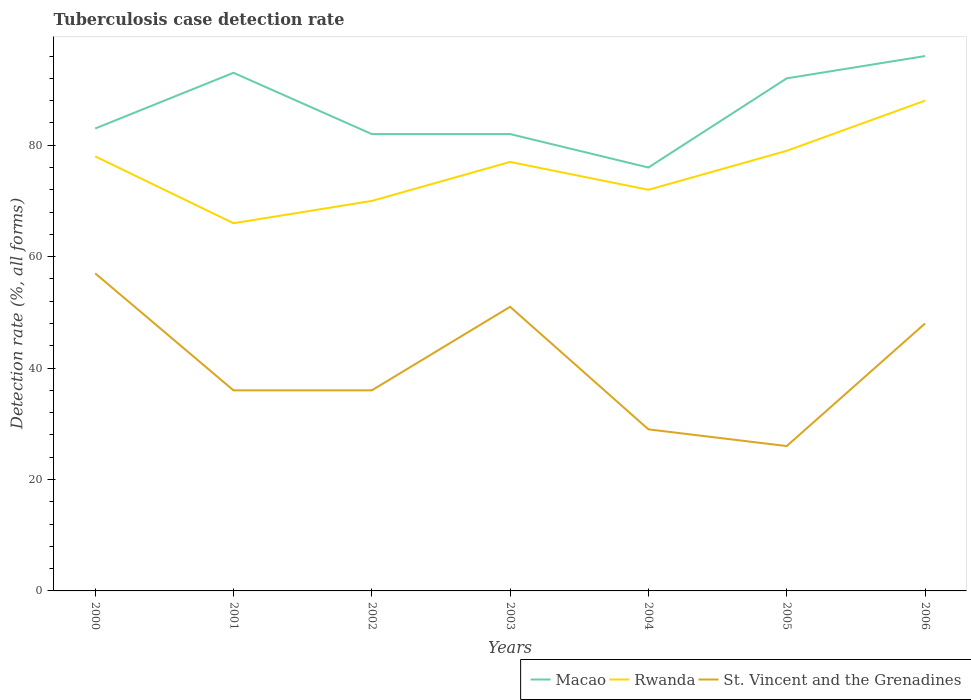Across all years, what is the maximum tuberculosis case detection rate in in Rwanda?
Provide a succinct answer. 66. What is the total tuberculosis case detection rate in in St. Vincent and the Grenadines in the graph?
Offer a terse response. 7. What is the difference between the highest and the second highest tuberculosis case detection rate in in St. Vincent and the Grenadines?
Ensure brevity in your answer.  31. What is the difference between the highest and the lowest tuberculosis case detection rate in in Macao?
Your response must be concise. 3. How many lines are there?
Provide a succinct answer. 3. What is the difference between two consecutive major ticks on the Y-axis?
Provide a short and direct response. 20. Does the graph contain grids?
Your answer should be compact. No. Where does the legend appear in the graph?
Offer a very short reply. Bottom right. How are the legend labels stacked?
Your response must be concise. Horizontal. What is the title of the graph?
Your answer should be very brief. Tuberculosis case detection rate. Does "Costa Rica" appear as one of the legend labels in the graph?
Give a very brief answer. No. What is the label or title of the X-axis?
Your response must be concise. Years. What is the label or title of the Y-axis?
Your answer should be compact. Detection rate (%, all forms). What is the Detection rate (%, all forms) of Macao in 2001?
Keep it short and to the point. 93. What is the Detection rate (%, all forms) of St. Vincent and the Grenadines in 2001?
Make the answer very short. 36. What is the Detection rate (%, all forms) of Macao in 2002?
Provide a succinct answer. 82. What is the Detection rate (%, all forms) in Macao in 2003?
Offer a terse response. 82. What is the Detection rate (%, all forms) in St. Vincent and the Grenadines in 2004?
Provide a succinct answer. 29. What is the Detection rate (%, all forms) of Macao in 2005?
Offer a terse response. 92. What is the Detection rate (%, all forms) in Rwanda in 2005?
Provide a succinct answer. 79. What is the Detection rate (%, all forms) of St. Vincent and the Grenadines in 2005?
Your response must be concise. 26. What is the Detection rate (%, all forms) in Macao in 2006?
Make the answer very short. 96. What is the Detection rate (%, all forms) in Rwanda in 2006?
Your answer should be very brief. 88. Across all years, what is the maximum Detection rate (%, all forms) of Macao?
Make the answer very short. 96. Across all years, what is the maximum Detection rate (%, all forms) of Rwanda?
Ensure brevity in your answer.  88. Across all years, what is the maximum Detection rate (%, all forms) in St. Vincent and the Grenadines?
Your response must be concise. 57. Across all years, what is the minimum Detection rate (%, all forms) of Macao?
Give a very brief answer. 76. Across all years, what is the minimum Detection rate (%, all forms) in St. Vincent and the Grenadines?
Keep it short and to the point. 26. What is the total Detection rate (%, all forms) of Macao in the graph?
Give a very brief answer. 604. What is the total Detection rate (%, all forms) in Rwanda in the graph?
Offer a very short reply. 530. What is the total Detection rate (%, all forms) in St. Vincent and the Grenadines in the graph?
Ensure brevity in your answer.  283. What is the difference between the Detection rate (%, all forms) in Macao in 2000 and that in 2001?
Provide a succinct answer. -10. What is the difference between the Detection rate (%, all forms) of Rwanda in 2000 and that in 2002?
Provide a short and direct response. 8. What is the difference between the Detection rate (%, all forms) of Rwanda in 2000 and that in 2003?
Your answer should be very brief. 1. What is the difference between the Detection rate (%, all forms) in St. Vincent and the Grenadines in 2000 and that in 2003?
Provide a short and direct response. 6. What is the difference between the Detection rate (%, all forms) of St. Vincent and the Grenadines in 2000 and that in 2004?
Your answer should be very brief. 28. What is the difference between the Detection rate (%, all forms) of St. Vincent and the Grenadines in 2000 and that in 2005?
Keep it short and to the point. 31. What is the difference between the Detection rate (%, all forms) of St. Vincent and the Grenadines in 2000 and that in 2006?
Your answer should be compact. 9. What is the difference between the Detection rate (%, all forms) in St. Vincent and the Grenadines in 2001 and that in 2002?
Provide a succinct answer. 0. What is the difference between the Detection rate (%, all forms) in Macao in 2001 and that in 2003?
Provide a succinct answer. 11. What is the difference between the Detection rate (%, all forms) in St. Vincent and the Grenadines in 2001 and that in 2003?
Offer a terse response. -15. What is the difference between the Detection rate (%, all forms) of Macao in 2001 and that in 2004?
Offer a very short reply. 17. What is the difference between the Detection rate (%, all forms) in St. Vincent and the Grenadines in 2001 and that in 2004?
Ensure brevity in your answer.  7. What is the difference between the Detection rate (%, all forms) of St. Vincent and the Grenadines in 2001 and that in 2005?
Make the answer very short. 10. What is the difference between the Detection rate (%, all forms) of Rwanda in 2001 and that in 2006?
Your response must be concise. -22. What is the difference between the Detection rate (%, all forms) in St. Vincent and the Grenadines in 2001 and that in 2006?
Make the answer very short. -12. What is the difference between the Detection rate (%, all forms) in Rwanda in 2002 and that in 2003?
Offer a terse response. -7. What is the difference between the Detection rate (%, all forms) in Macao in 2002 and that in 2004?
Your response must be concise. 6. What is the difference between the Detection rate (%, all forms) of Rwanda in 2002 and that in 2004?
Your answer should be compact. -2. What is the difference between the Detection rate (%, all forms) in St. Vincent and the Grenadines in 2002 and that in 2004?
Ensure brevity in your answer.  7. What is the difference between the Detection rate (%, all forms) in St. Vincent and the Grenadines in 2002 and that in 2005?
Provide a short and direct response. 10. What is the difference between the Detection rate (%, all forms) of Macao in 2002 and that in 2006?
Keep it short and to the point. -14. What is the difference between the Detection rate (%, all forms) of Rwanda in 2002 and that in 2006?
Provide a short and direct response. -18. What is the difference between the Detection rate (%, all forms) of St. Vincent and the Grenadines in 2002 and that in 2006?
Provide a short and direct response. -12. What is the difference between the Detection rate (%, all forms) in Macao in 2003 and that in 2004?
Offer a terse response. 6. What is the difference between the Detection rate (%, all forms) of St. Vincent and the Grenadines in 2003 and that in 2004?
Offer a very short reply. 22. What is the difference between the Detection rate (%, all forms) in Macao in 2003 and that in 2005?
Keep it short and to the point. -10. What is the difference between the Detection rate (%, all forms) of Rwanda in 2003 and that in 2005?
Keep it short and to the point. -2. What is the difference between the Detection rate (%, all forms) in St. Vincent and the Grenadines in 2003 and that in 2006?
Your answer should be compact. 3. What is the difference between the Detection rate (%, all forms) of Rwanda in 2004 and that in 2005?
Your answer should be compact. -7. What is the difference between the Detection rate (%, all forms) in Macao in 2004 and that in 2006?
Offer a very short reply. -20. What is the difference between the Detection rate (%, all forms) of Rwanda in 2004 and that in 2006?
Give a very brief answer. -16. What is the difference between the Detection rate (%, all forms) of Macao in 2005 and that in 2006?
Your answer should be very brief. -4. What is the difference between the Detection rate (%, all forms) of Rwanda in 2005 and that in 2006?
Your answer should be compact. -9. What is the difference between the Detection rate (%, all forms) of St. Vincent and the Grenadines in 2005 and that in 2006?
Your answer should be compact. -22. What is the difference between the Detection rate (%, all forms) of Macao in 2000 and the Detection rate (%, all forms) of Rwanda in 2001?
Provide a short and direct response. 17. What is the difference between the Detection rate (%, all forms) of Macao in 2000 and the Detection rate (%, all forms) of St. Vincent and the Grenadines in 2001?
Your answer should be very brief. 47. What is the difference between the Detection rate (%, all forms) in Rwanda in 2000 and the Detection rate (%, all forms) in St. Vincent and the Grenadines in 2002?
Offer a very short reply. 42. What is the difference between the Detection rate (%, all forms) in Macao in 2000 and the Detection rate (%, all forms) in St. Vincent and the Grenadines in 2003?
Provide a short and direct response. 32. What is the difference between the Detection rate (%, all forms) of Rwanda in 2000 and the Detection rate (%, all forms) of St. Vincent and the Grenadines in 2003?
Your answer should be very brief. 27. What is the difference between the Detection rate (%, all forms) in Macao in 2000 and the Detection rate (%, all forms) in St. Vincent and the Grenadines in 2004?
Offer a very short reply. 54. What is the difference between the Detection rate (%, all forms) of Macao in 2000 and the Detection rate (%, all forms) of Rwanda in 2005?
Offer a very short reply. 4. What is the difference between the Detection rate (%, all forms) of Macao in 2000 and the Detection rate (%, all forms) of Rwanda in 2006?
Your answer should be compact. -5. What is the difference between the Detection rate (%, all forms) in Macao in 2001 and the Detection rate (%, all forms) in Rwanda in 2002?
Make the answer very short. 23. What is the difference between the Detection rate (%, all forms) in Rwanda in 2001 and the Detection rate (%, all forms) in St. Vincent and the Grenadines in 2002?
Provide a short and direct response. 30. What is the difference between the Detection rate (%, all forms) of Macao in 2001 and the Detection rate (%, all forms) of Rwanda in 2003?
Keep it short and to the point. 16. What is the difference between the Detection rate (%, all forms) in Macao in 2001 and the Detection rate (%, all forms) in Rwanda in 2005?
Keep it short and to the point. 14. What is the difference between the Detection rate (%, all forms) of Macao in 2001 and the Detection rate (%, all forms) of St. Vincent and the Grenadines in 2005?
Make the answer very short. 67. What is the difference between the Detection rate (%, all forms) in Macao in 2001 and the Detection rate (%, all forms) in Rwanda in 2006?
Your response must be concise. 5. What is the difference between the Detection rate (%, all forms) in Macao in 2002 and the Detection rate (%, all forms) in Rwanda in 2003?
Offer a very short reply. 5. What is the difference between the Detection rate (%, all forms) of Macao in 2002 and the Detection rate (%, all forms) of Rwanda in 2004?
Give a very brief answer. 10. What is the difference between the Detection rate (%, all forms) in Macao in 2002 and the Detection rate (%, all forms) in St. Vincent and the Grenadines in 2004?
Ensure brevity in your answer.  53. What is the difference between the Detection rate (%, all forms) in Macao in 2002 and the Detection rate (%, all forms) in Rwanda in 2005?
Give a very brief answer. 3. What is the difference between the Detection rate (%, all forms) in Macao in 2002 and the Detection rate (%, all forms) in St. Vincent and the Grenadines in 2005?
Your answer should be compact. 56. What is the difference between the Detection rate (%, all forms) in Rwanda in 2002 and the Detection rate (%, all forms) in St. Vincent and the Grenadines in 2005?
Ensure brevity in your answer.  44. What is the difference between the Detection rate (%, all forms) of Macao in 2002 and the Detection rate (%, all forms) of Rwanda in 2006?
Provide a short and direct response. -6. What is the difference between the Detection rate (%, all forms) of Rwanda in 2002 and the Detection rate (%, all forms) of St. Vincent and the Grenadines in 2006?
Your answer should be very brief. 22. What is the difference between the Detection rate (%, all forms) of Macao in 2003 and the Detection rate (%, all forms) of Rwanda in 2004?
Your answer should be very brief. 10. What is the difference between the Detection rate (%, all forms) in Macao in 2003 and the Detection rate (%, all forms) in Rwanda in 2005?
Ensure brevity in your answer.  3. What is the difference between the Detection rate (%, all forms) of Macao in 2004 and the Detection rate (%, all forms) of Rwanda in 2005?
Offer a very short reply. -3. What is the difference between the Detection rate (%, all forms) of Macao in 2004 and the Detection rate (%, all forms) of St. Vincent and the Grenadines in 2005?
Offer a terse response. 50. What is the difference between the Detection rate (%, all forms) of Macao in 2004 and the Detection rate (%, all forms) of Rwanda in 2006?
Provide a short and direct response. -12. What is the difference between the Detection rate (%, all forms) in Macao in 2004 and the Detection rate (%, all forms) in St. Vincent and the Grenadines in 2006?
Your response must be concise. 28. What is the difference between the Detection rate (%, all forms) of Macao in 2005 and the Detection rate (%, all forms) of Rwanda in 2006?
Your answer should be very brief. 4. What is the difference between the Detection rate (%, all forms) of Macao in 2005 and the Detection rate (%, all forms) of St. Vincent and the Grenadines in 2006?
Keep it short and to the point. 44. What is the difference between the Detection rate (%, all forms) of Rwanda in 2005 and the Detection rate (%, all forms) of St. Vincent and the Grenadines in 2006?
Offer a terse response. 31. What is the average Detection rate (%, all forms) of Macao per year?
Offer a very short reply. 86.29. What is the average Detection rate (%, all forms) of Rwanda per year?
Your answer should be very brief. 75.71. What is the average Detection rate (%, all forms) in St. Vincent and the Grenadines per year?
Keep it short and to the point. 40.43. In the year 2000, what is the difference between the Detection rate (%, all forms) in Macao and Detection rate (%, all forms) in Rwanda?
Keep it short and to the point. 5. In the year 2000, what is the difference between the Detection rate (%, all forms) of Macao and Detection rate (%, all forms) of St. Vincent and the Grenadines?
Keep it short and to the point. 26. In the year 2001, what is the difference between the Detection rate (%, all forms) in Macao and Detection rate (%, all forms) in Rwanda?
Your response must be concise. 27. In the year 2002, what is the difference between the Detection rate (%, all forms) of Macao and Detection rate (%, all forms) of Rwanda?
Give a very brief answer. 12. In the year 2003, what is the difference between the Detection rate (%, all forms) in Rwanda and Detection rate (%, all forms) in St. Vincent and the Grenadines?
Make the answer very short. 26. In the year 2005, what is the difference between the Detection rate (%, all forms) in Macao and Detection rate (%, all forms) in Rwanda?
Provide a succinct answer. 13. In the year 2005, what is the difference between the Detection rate (%, all forms) in Rwanda and Detection rate (%, all forms) in St. Vincent and the Grenadines?
Your answer should be very brief. 53. In the year 2006, what is the difference between the Detection rate (%, all forms) in Macao and Detection rate (%, all forms) in Rwanda?
Offer a very short reply. 8. In the year 2006, what is the difference between the Detection rate (%, all forms) in Rwanda and Detection rate (%, all forms) in St. Vincent and the Grenadines?
Offer a terse response. 40. What is the ratio of the Detection rate (%, all forms) in Macao in 2000 to that in 2001?
Make the answer very short. 0.89. What is the ratio of the Detection rate (%, all forms) of Rwanda in 2000 to that in 2001?
Provide a short and direct response. 1.18. What is the ratio of the Detection rate (%, all forms) of St. Vincent and the Grenadines in 2000 to that in 2001?
Give a very brief answer. 1.58. What is the ratio of the Detection rate (%, all forms) in Macao in 2000 to that in 2002?
Give a very brief answer. 1.01. What is the ratio of the Detection rate (%, all forms) in Rwanda in 2000 to that in 2002?
Ensure brevity in your answer.  1.11. What is the ratio of the Detection rate (%, all forms) in St. Vincent and the Grenadines in 2000 to that in 2002?
Your answer should be very brief. 1.58. What is the ratio of the Detection rate (%, all forms) of Macao in 2000 to that in 2003?
Provide a short and direct response. 1.01. What is the ratio of the Detection rate (%, all forms) of Rwanda in 2000 to that in 2003?
Your answer should be very brief. 1.01. What is the ratio of the Detection rate (%, all forms) of St. Vincent and the Grenadines in 2000 to that in 2003?
Keep it short and to the point. 1.12. What is the ratio of the Detection rate (%, all forms) of Macao in 2000 to that in 2004?
Ensure brevity in your answer.  1.09. What is the ratio of the Detection rate (%, all forms) in Rwanda in 2000 to that in 2004?
Keep it short and to the point. 1.08. What is the ratio of the Detection rate (%, all forms) of St. Vincent and the Grenadines in 2000 to that in 2004?
Offer a terse response. 1.97. What is the ratio of the Detection rate (%, all forms) of Macao in 2000 to that in 2005?
Keep it short and to the point. 0.9. What is the ratio of the Detection rate (%, all forms) of Rwanda in 2000 to that in 2005?
Your answer should be very brief. 0.99. What is the ratio of the Detection rate (%, all forms) in St. Vincent and the Grenadines in 2000 to that in 2005?
Ensure brevity in your answer.  2.19. What is the ratio of the Detection rate (%, all forms) of Macao in 2000 to that in 2006?
Keep it short and to the point. 0.86. What is the ratio of the Detection rate (%, all forms) in Rwanda in 2000 to that in 2006?
Make the answer very short. 0.89. What is the ratio of the Detection rate (%, all forms) in St. Vincent and the Grenadines in 2000 to that in 2006?
Keep it short and to the point. 1.19. What is the ratio of the Detection rate (%, all forms) of Macao in 2001 to that in 2002?
Provide a short and direct response. 1.13. What is the ratio of the Detection rate (%, all forms) of Rwanda in 2001 to that in 2002?
Offer a very short reply. 0.94. What is the ratio of the Detection rate (%, all forms) of Macao in 2001 to that in 2003?
Give a very brief answer. 1.13. What is the ratio of the Detection rate (%, all forms) in Rwanda in 2001 to that in 2003?
Provide a short and direct response. 0.86. What is the ratio of the Detection rate (%, all forms) of St. Vincent and the Grenadines in 2001 to that in 2003?
Keep it short and to the point. 0.71. What is the ratio of the Detection rate (%, all forms) in Macao in 2001 to that in 2004?
Keep it short and to the point. 1.22. What is the ratio of the Detection rate (%, all forms) in St. Vincent and the Grenadines in 2001 to that in 2004?
Give a very brief answer. 1.24. What is the ratio of the Detection rate (%, all forms) of Macao in 2001 to that in 2005?
Provide a short and direct response. 1.01. What is the ratio of the Detection rate (%, all forms) in Rwanda in 2001 to that in 2005?
Your answer should be compact. 0.84. What is the ratio of the Detection rate (%, all forms) in St. Vincent and the Grenadines in 2001 to that in 2005?
Offer a terse response. 1.38. What is the ratio of the Detection rate (%, all forms) of Macao in 2001 to that in 2006?
Your response must be concise. 0.97. What is the ratio of the Detection rate (%, all forms) of Rwanda in 2001 to that in 2006?
Ensure brevity in your answer.  0.75. What is the ratio of the Detection rate (%, all forms) in St. Vincent and the Grenadines in 2001 to that in 2006?
Give a very brief answer. 0.75. What is the ratio of the Detection rate (%, all forms) of Macao in 2002 to that in 2003?
Your answer should be very brief. 1. What is the ratio of the Detection rate (%, all forms) of Rwanda in 2002 to that in 2003?
Ensure brevity in your answer.  0.91. What is the ratio of the Detection rate (%, all forms) in St. Vincent and the Grenadines in 2002 to that in 2003?
Provide a succinct answer. 0.71. What is the ratio of the Detection rate (%, all forms) in Macao in 2002 to that in 2004?
Your answer should be very brief. 1.08. What is the ratio of the Detection rate (%, all forms) of Rwanda in 2002 to that in 2004?
Provide a succinct answer. 0.97. What is the ratio of the Detection rate (%, all forms) of St. Vincent and the Grenadines in 2002 to that in 2004?
Provide a succinct answer. 1.24. What is the ratio of the Detection rate (%, all forms) in Macao in 2002 to that in 2005?
Offer a very short reply. 0.89. What is the ratio of the Detection rate (%, all forms) of Rwanda in 2002 to that in 2005?
Offer a terse response. 0.89. What is the ratio of the Detection rate (%, all forms) in St. Vincent and the Grenadines in 2002 to that in 2005?
Your answer should be very brief. 1.38. What is the ratio of the Detection rate (%, all forms) of Macao in 2002 to that in 2006?
Your answer should be compact. 0.85. What is the ratio of the Detection rate (%, all forms) in Rwanda in 2002 to that in 2006?
Your response must be concise. 0.8. What is the ratio of the Detection rate (%, all forms) of Macao in 2003 to that in 2004?
Your answer should be compact. 1.08. What is the ratio of the Detection rate (%, all forms) in Rwanda in 2003 to that in 2004?
Keep it short and to the point. 1.07. What is the ratio of the Detection rate (%, all forms) of St. Vincent and the Grenadines in 2003 to that in 2004?
Provide a short and direct response. 1.76. What is the ratio of the Detection rate (%, all forms) of Macao in 2003 to that in 2005?
Keep it short and to the point. 0.89. What is the ratio of the Detection rate (%, all forms) of Rwanda in 2003 to that in 2005?
Offer a very short reply. 0.97. What is the ratio of the Detection rate (%, all forms) of St. Vincent and the Grenadines in 2003 to that in 2005?
Keep it short and to the point. 1.96. What is the ratio of the Detection rate (%, all forms) in Macao in 2003 to that in 2006?
Give a very brief answer. 0.85. What is the ratio of the Detection rate (%, all forms) of Rwanda in 2003 to that in 2006?
Provide a short and direct response. 0.88. What is the ratio of the Detection rate (%, all forms) of Macao in 2004 to that in 2005?
Give a very brief answer. 0.83. What is the ratio of the Detection rate (%, all forms) of Rwanda in 2004 to that in 2005?
Provide a short and direct response. 0.91. What is the ratio of the Detection rate (%, all forms) in St. Vincent and the Grenadines in 2004 to that in 2005?
Your answer should be compact. 1.12. What is the ratio of the Detection rate (%, all forms) of Macao in 2004 to that in 2006?
Ensure brevity in your answer.  0.79. What is the ratio of the Detection rate (%, all forms) of Rwanda in 2004 to that in 2006?
Provide a short and direct response. 0.82. What is the ratio of the Detection rate (%, all forms) of St. Vincent and the Grenadines in 2004 to that in 2006?
Make the answer very short. 0.6. What is the ratio of the Detection rate (%, all forms) of Rwanda in 2005 to that in 2006?
Offer a terse response. 0.9. What is the ratio of the Detection rate (%, all forms) in St. Vincent and the Grenadines in 2005 to that in 2006?
Keep it short and to the point. 0.54. What is the difference between the highest and the second highest Detection rate (%, all forms) of Macao?
Provide a short and direct response. 3. What is the difference between the highest and the lowest Detection rate (%, all forms) of Rwanda?
Your answer should be very brief. 22. 